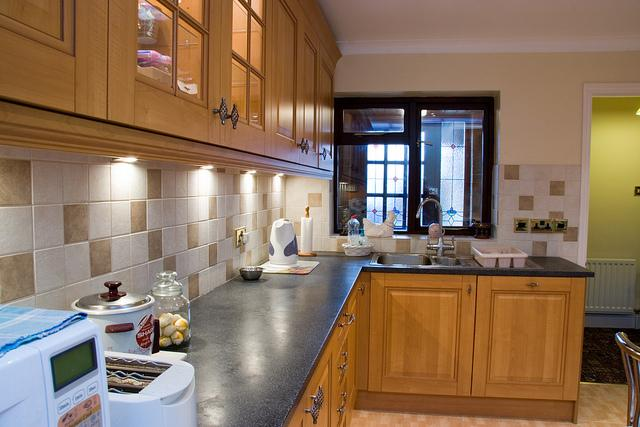What appliance is next to the microwave?

Choices:
A) refrigerator
B) toaster
C) oven
D) dishwasher toaster 